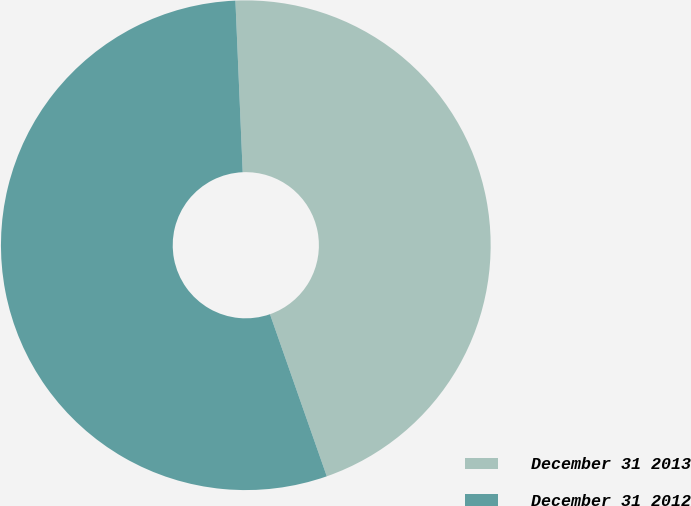Convert chart. <chart><loc_0><loc_0><loc_500><loc_500><pie_chart><fcel>December 31 2013<fcel>December 31 2012<nl><fcel>45.31%<fcel>54.69%<nl></chart> 